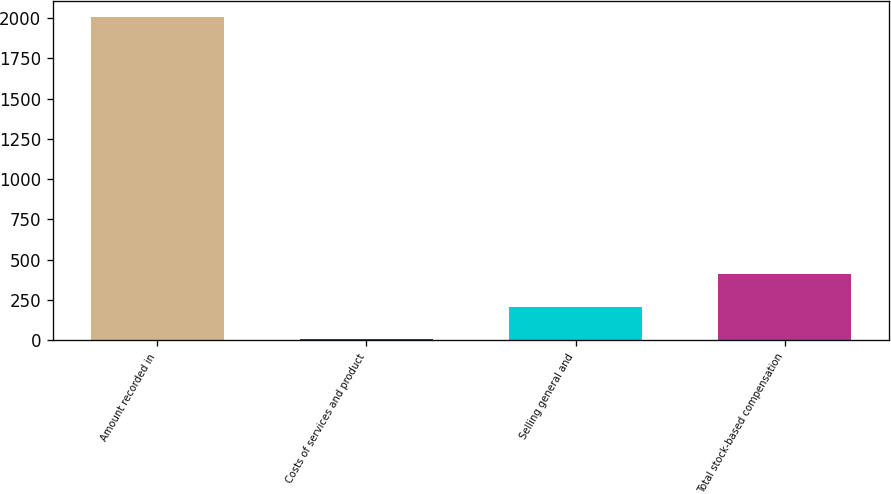<chart> <loc_0><loc_0><loc_500><loc_500><bar_chart><fcel>Amount recorded in<fcel>Costs of services and product<fcel>Selling general and<fcel>Total stock-based compensation<nl><fcel>2008<fcel>9.6<fcel>209.44<fcel>409.28<nl></chart> 